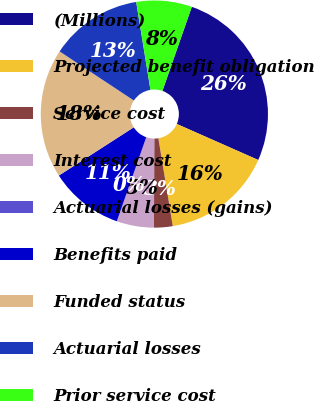<chart> <loc_0><loc_0><loc_500><loc_500><pie_chart><fcel>(Millions)<fcel>Projected benefit obligation<fcel>Service cost<fcel>Interest cost<fcel>Actuarial losses (gains)<fcel>Benefits paid<fcel>Funded status<fcel>Actuarial losses<fcel>Prior service cost<nl><fcel>26.28%<fcel>15.78%<fcel>2.65%<fcel>5.28%<fcel>0.03%<fcel>10.53%<fcel>18.4%<fcel>13.15%<fcel>7.9%<nl></chart> 